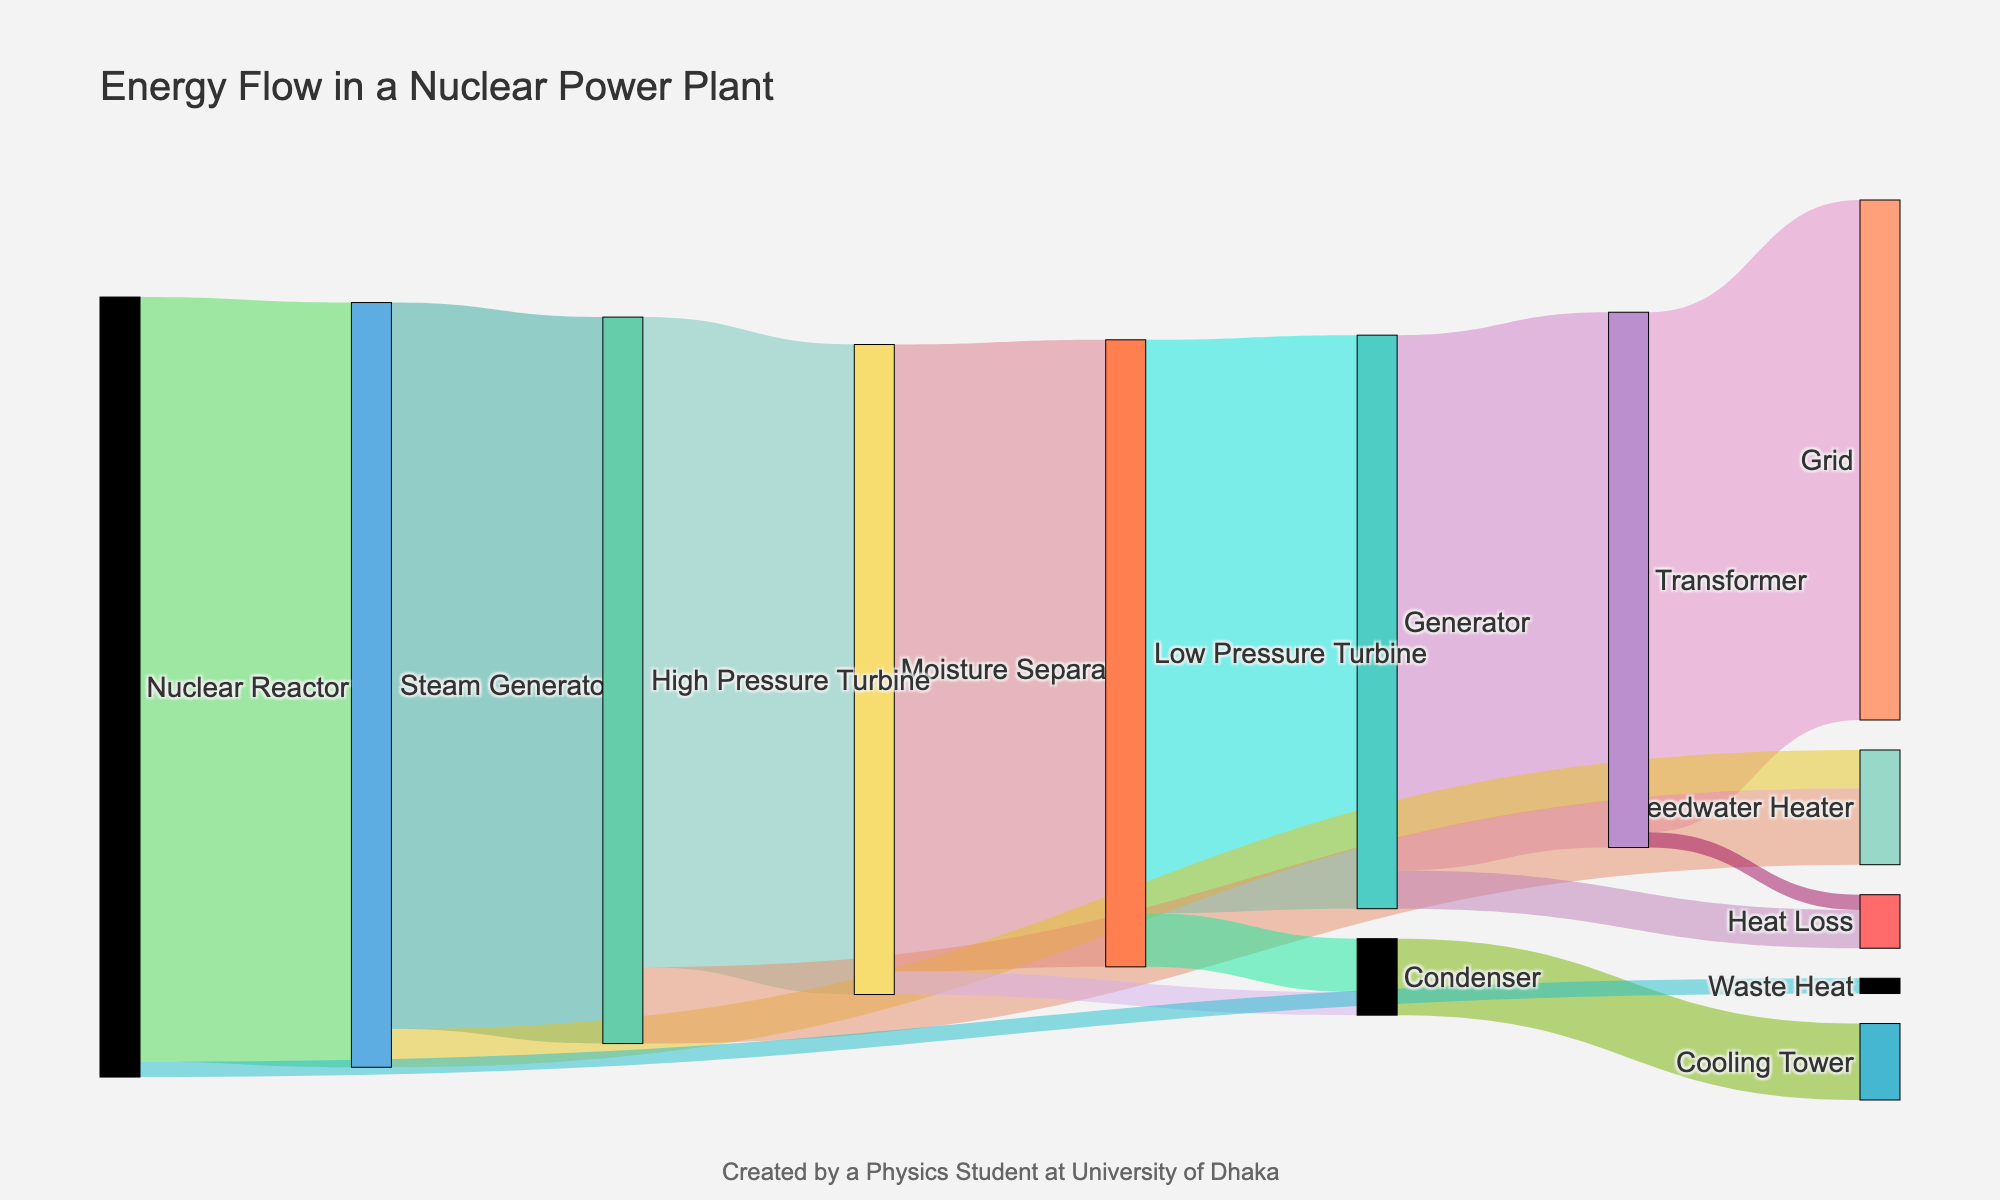who are the sources and targets in the figure? The figure shows the energy flow through various stages in a nuclear power plant. The sources are the initial stages where energy originates, and the targets are subsequent stages where energy flows. In this figure, the sources are 'Nuclear Reactor', 'Steam Generator', 'High Pressure Turbine', and so forth, whereas the targets include 'Steam Generator', 'High Pressure Turbine', 'Moisture Separator', and other stages listed in the data.
Answer: 'Nuclear Reactor', 'Steam Generator', 'High Pressure Turbine', etc What is the title of the figure? The title of the figure is displayed prominently at the top. It describes the main subject of the figure, which is the energy distribution across different stages of power generation in a nuclear power plant.
Answer: Energy Flow in a Nuclear Power Plant Which node has the largest outgoing energy flow? By examining the widths of the flows originating from each node, we can identify the stage with the largest outgoing flow. The 'Nuclear Reactor' node has the largest outgoing flow with a value of 100 units.
Answer: Nuclear Reactor How much energy is lost as waste heat from the Nuclear Reactor? The figure indicates this by showing a flow labeled 'Waste Heat' originating from the 'Nuclear Reactor' node. The value is shown next to this flow.
Answer: 2 units Compare the energy lost as heat from the Generator and the Transformer. Which one loses more and by how much? By observing the flows 'Heat Loss' originating from both 'Generator' and 'Transformer', the values are 5 units and 2 units respectively. Subtracting these, the Generator loses 3 more units of energy as heat compared to the Transformer.
Answer: Generator loses 3 units more What percentage of energy reaches the Grid relative to the total energy from the Nuclear Reactor? To find the percentage, first identify the energy reaching the Grid (68 units) and the total energy output from the Nuclear Reactor (100 units). The percentage is calculated as (68 / 100) * 100%.
Answer: 68% Calculate the total energy flowing to the Feedwater Heater from different stages. Summing up the energy contributions to the Feedwater Heater from 'Steam Generator' (5 units) and 'High Pressure Turbine' (10 units), we get a total flow of 15 units.
Answer: 15 units Which stage has the least amount of energy flowing out of it? By comparing all the outgoing flows, we can identify that the 'Condenser' has outgoing flows of 10 units, which is the least amount of energy flowing out of any node.
Answer: Condenser What is the final energy delivered to the 'Grid'? By looking at the final flow directed towards the 'Grid' node, the amount of energy delivered is 68 units.
Answer: 68 units 